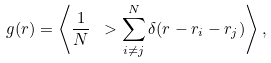Convert formula to latex. <formula><loc_0><loc_0><loc_500><loc_500>g ( r ) = \left \langle \frac { 1 } { N } \ > \sum _ { i \neq j } ^ { N } \delta ( { r } - { r _ { i } } - { r _ { j } } ) \right \rangle ,</formula> 